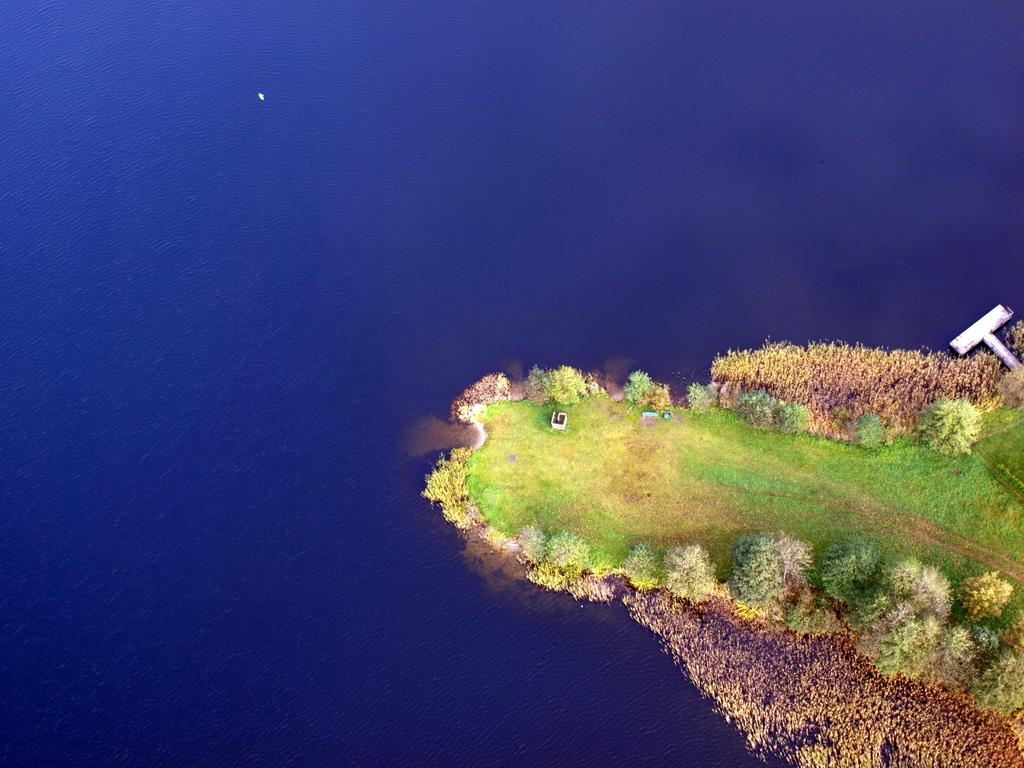What geographical feature is the main subject of the image? There is an island in the image. What type of vegetation can be seen on the island? The island has trees and plants. What is the primary composition of the island? The island has land and grass. What can be seen on the left side of the image? There is water on the left side of the image. Can you hear the chair crying in the image? There is no chair or any indication of crying in the image; it features an island with trees, plants, land, grass, and water. 